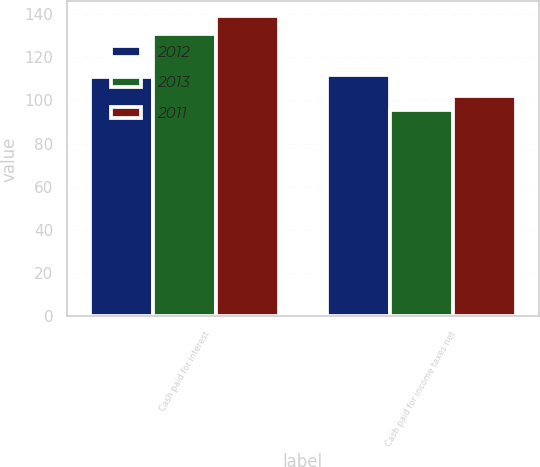<chart> <loc_0><loc_0><loc_500><loc_500><stacked_bar_chart><ecel><fcel>Cash paid for interest<fcel>Cash paid for income taxes net<nl><fcel>2012<fcel>110.7<fcel>111.8<nl><fcel>2013<fcel>130.6<fcel>95.7<nl><fcel>2011<fcel>138.9<fcel>102<nl></chart> 